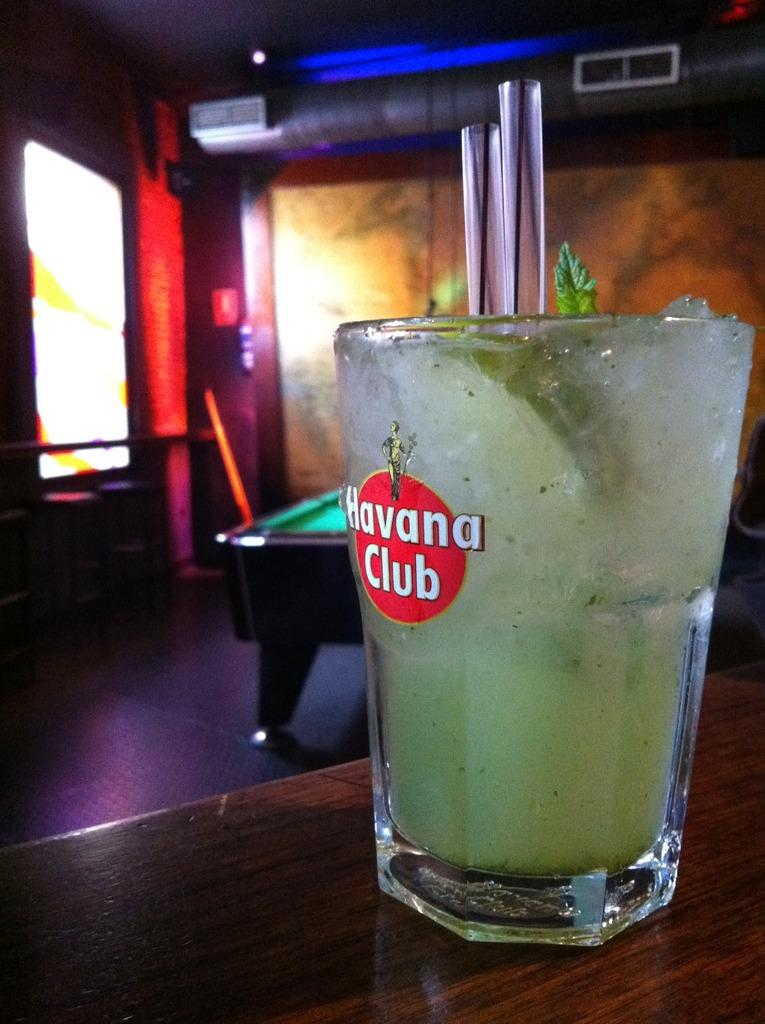What is in the glass that is visible in the image? There is a juice glass in the glass in the image. Where is the juice glass located? The juice glass is kept on a table. What other object can be seen in the image? There is a billiards board visible in the image. What type of dock can be seen near the billiards board in the image? There is no dock present in the image; it features a juice glass on a table and a billiards board. 